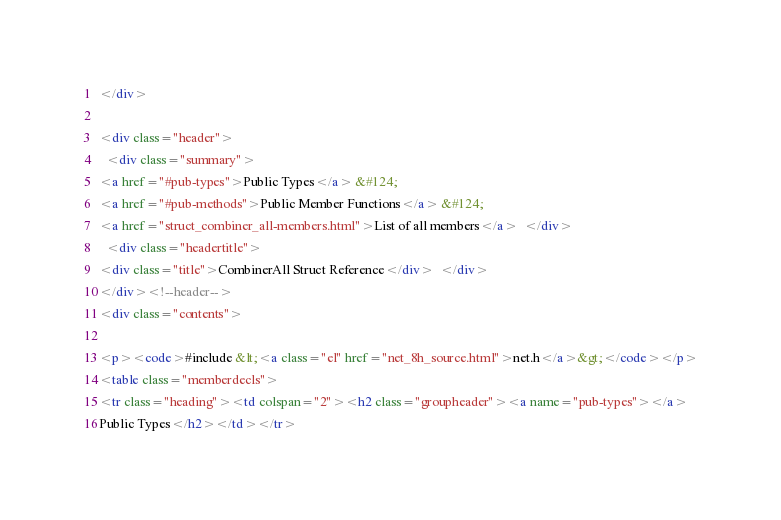<code> <loc_0><loc_0><loc_500><loc_500><_HTML_></div>

<div class="header">
  <div class="summary">
<a href="#pub-types">Public Types</a> &#124;
<a href="#pub-methods">Public Member Functions</a> &#124;
<a href="struct_combiner_all-members.html">List of all members</a>  </div>
  <div class="headertitle">
<div class="title">CombinerAll Struct Reference</div>  </div>
</div><!--header-->
<div class="contents">

<p><code>#include &lt;<a class="el" href="net_8h_source.html">net.h</a>&gt;</code></p>
<table class="memberdecls">
<tr class="heading"><td colspan="2"><h2 class="groupheader"><a name="pub-types"></a>
Public Types</h2></td></tr></code> 